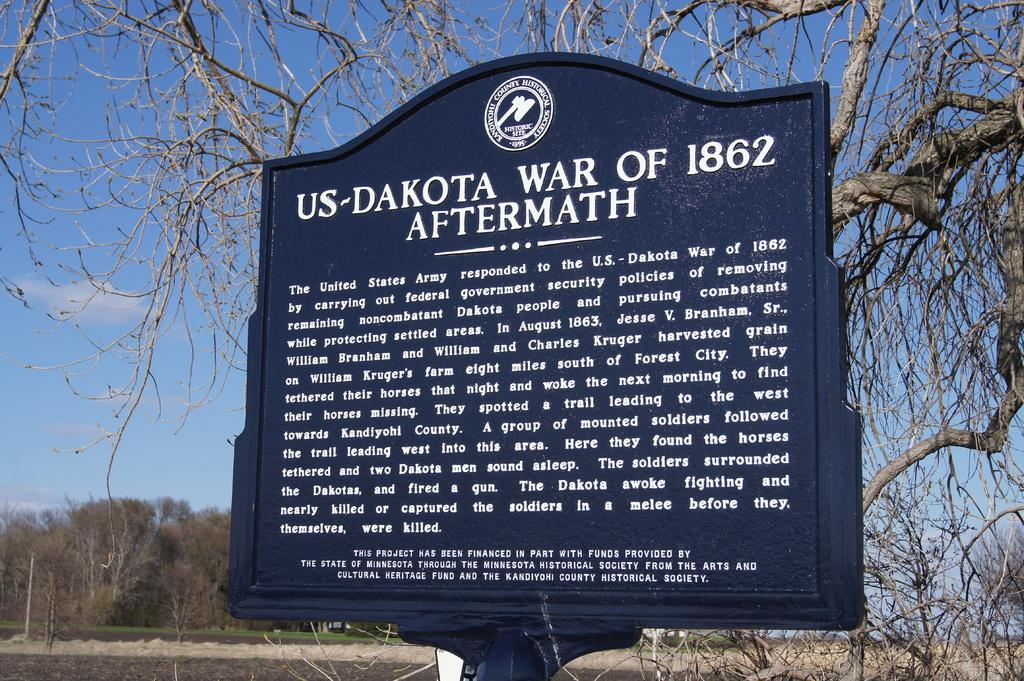What is the main object in the image? There is a sign board in the image. Where is the sign board located? The sign board is placed under a tree. What can be seen in the background of the image? There are trees and the sky visible in the background of the image. Can you tell me how many horses are standing near the sign board in the image? There are no horses present in the image; it only features a sign board placed under a tree. What type of pleasure can be derived from the sign board in the image? The image does not convey any information about pleasure or enjoyment related to the sign board. 